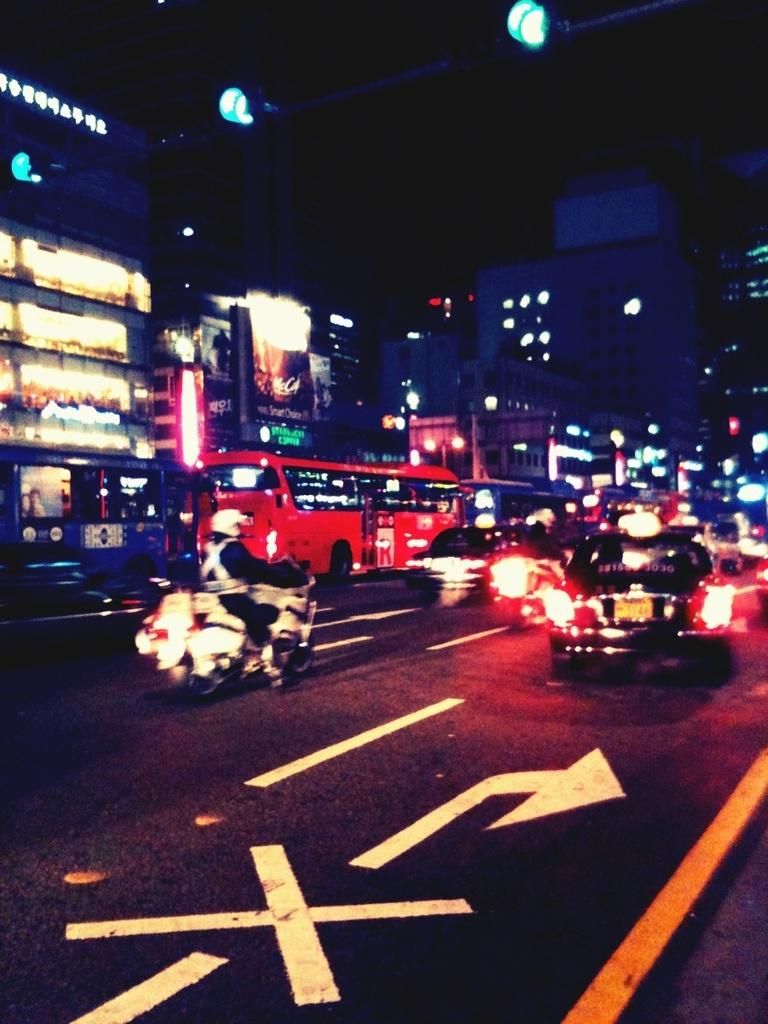What is the main subject of the image? The main subject of the image is vehicles. What are the vehicles doing in the image? The vehicles are moving on the road. What can be seen in the background of the image? There are buildings and traffic signals in the background of the image. What type of spring can be seen on the wrist of the driver in the image? There is no driver or wrist visible in the image, so it is not possible to determine if there is a spring present. 